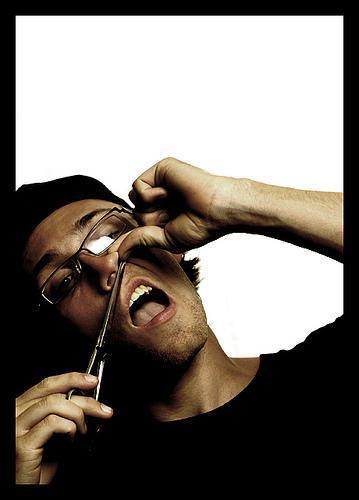How many men are in the photo?
Give a very brief answer. 1. 